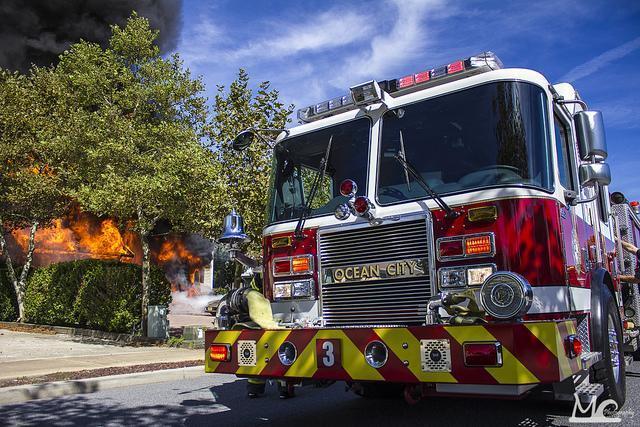How many people are in this truck?
Give a very brief answer. 0. 